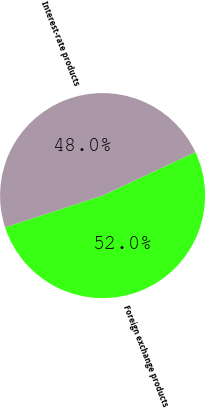<chart> <loc_0><loc_0><loc_500><loc_500><pie_chart><fcel>Foreign exchange products<fcel>Interest-rate products<nl><fcel>51.95%<fcel>48.05%<nl></chart> 